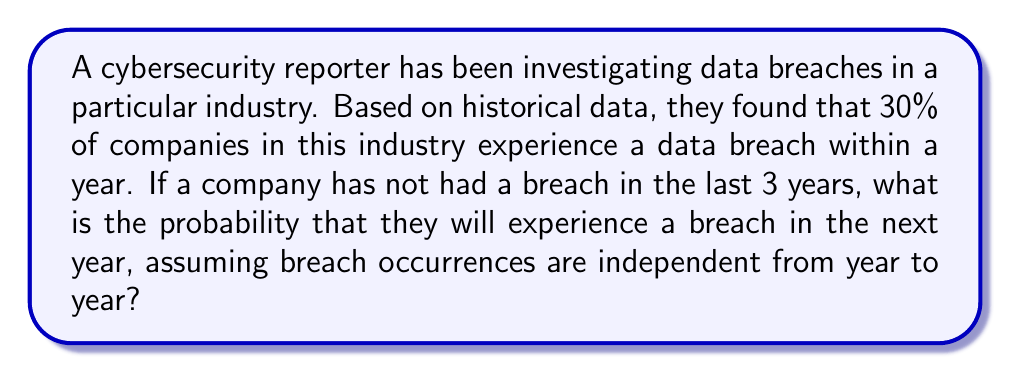Give your solution to this math problem. To solve this problem, we'll use Bayesian reasoning and the concept of conditional probability. Let's break it down step by step:

1) Let's define our events:
   A: The company experiences a breach in the next year
   B: The company has not had a breach in the last 3 years

2) We're given:
   P(A) = 0.30 (30% chance of a breach in any given year)
   
3) We need to calculate P(A|B), the probability of a breach in the next year given no breaches in the last 3 years.

4) To find P(A|B), we can use Bayes' theorem:

   $$P(A|B) = \frac{P(B|A) \cdot P(A)}{P(B)}$$

5) We know P(A), but we need to calculate P(B|A) and P(B):

   P(B|A) = Probability of no breaches in 3 years given a breach occurs in the 4th year
   = Probability of no breach for 3 independent years = $(0.7)^3$ = 0.343

   P(B) = Probability of no breaches in 3 years
   = $(0.7)^3$ = 0.343

6) Now we can plug these values into Bayes' theorem:

   $$P(A|B) = \frac{0.343 \cdot 0.30}{0.343} = 0.30$$

7) The probability simplifies to 0.30 or 30%.
Answer: The probability that the company will experience a data breach in the next year, given that they haven't had a breach in the last 3 years, is 0.30 or 30%. 